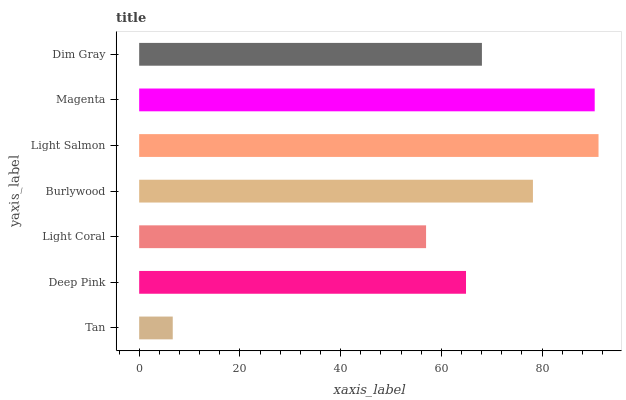Is Tan the minimum?
Answer yes or no. Yes. Is Light Salmon the maximum?
Answer yes or no. Yes. Is Deep Pink the minimum?
Answer yes or no. No. Is Deep Pink the maximum?
Answer yes or no. No. Is Deep Pink greater than Tan?
Answer yes or no. Yes. Is Tan less than Deep Pink?
Answer yes or no. Yes. Is Tan greater than Deep Pink?
Answer yes or no. No. Is Deep Pink less than Tan?
Answer yes or no. No. Is Dim Gray the high median?
Answer yes or no. Yes. Is Dim Gray the low median?
Answer yes or no. Yes. Is Magenta the high median?
Answer yes or no. No. Is Burlywood the low median?
Answer yes or no. No. 